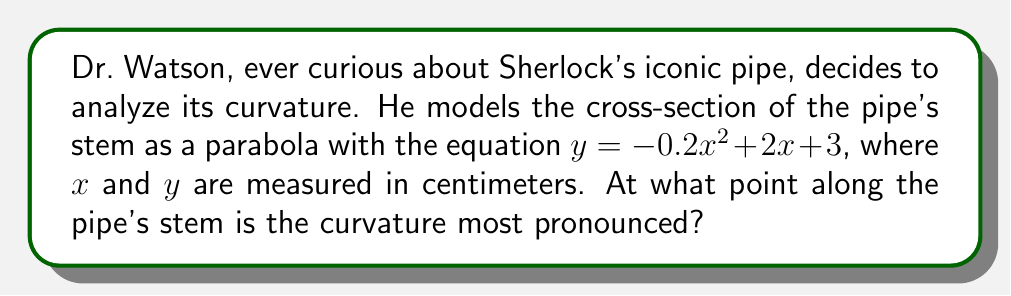Can you answer this question? To find the point of maximum curvature, we need to follow these steps:

1) The curvature of a function $y = f(x)$ is given by the formula:

   $$\kappa = \frac{|f''(x)|}{(1 + (f'(x))^2)^{3/2}}$$

2) First, let's find $f'(x)$ and $f''(x)$:
   
   $f'(x) = -0.4x + 2$
   $f''(x) = -0.4$

3) Since $f''(x)$ is constant, the numerator of our curvature formula will be constant. The point of maximum curvature will occur where the denominator is at its minimum.

4) Let's simplify the denominator:
   
   $(1 + (f'(x))^2)^{3/2} = (1 + (-0.4x + 2)^2)^{3/2}$

5) To find the minimum of this expression, we need to find where its derivative equals zero:

   $\frac{d}{dx}(1 + (-0.4x + 2)^2)^{3/2} = 0$

6) This occurs when $-0.4x + 2 = 0$, or when $x = 5$

7) Therefore, the curvature is most pronounced at the point $(5, y)$ on the parabola.

8) To find $y$, we substitute $x = 5$ into our original equation:

   $y = -0.2(5)^2 + 2(5) + 3 = -5 + 10 + 3 = 8$

Thus, the point of maximum curvature is (5, 8).
Answer: (5, 8) cm 